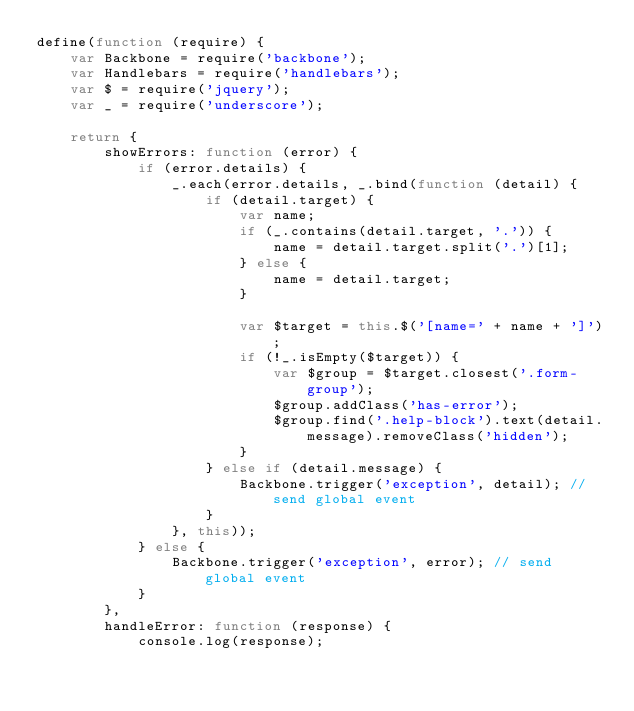Convert code to text. <code><loc_0><loc_0><loc_500><loc_500><_JavaScript_>define(function (require) {
    var Backbone = require('backbone');
    var Handlebars = require('handlebars');
    var $ = require('jquery');
    var _ = require('underscore');

    return {
        showErrors: function (error) {
            if (error.details) {
                _.each(error.details, _.bind(function (detail) {
                    if (detail.target) {
                        var name;
                        if (_.contains(detail.target, '.')) {
                            name = detail.target.split('.')[1];
                        } else {
                            name = detail.target;
                        }

                        var $target = this.$('[name=' + name + ']');
                        if (!_.isEmpty($target)) {
                            var $group = $target.closest('.form-group');
                            $group.addClass('has-error');
                            $group.find('.help-block').text(detail.message).removeClass('hidden');
                        }
                    } else if (detail.message) {
                        Backbone.trigger('exception', detail); // send global event
                    }
                }, this));
            } else {
                Backbone.trigger('exception', error); // send global event
            }
        },
        handleError: function (response) {
            console.log(response);</code> 